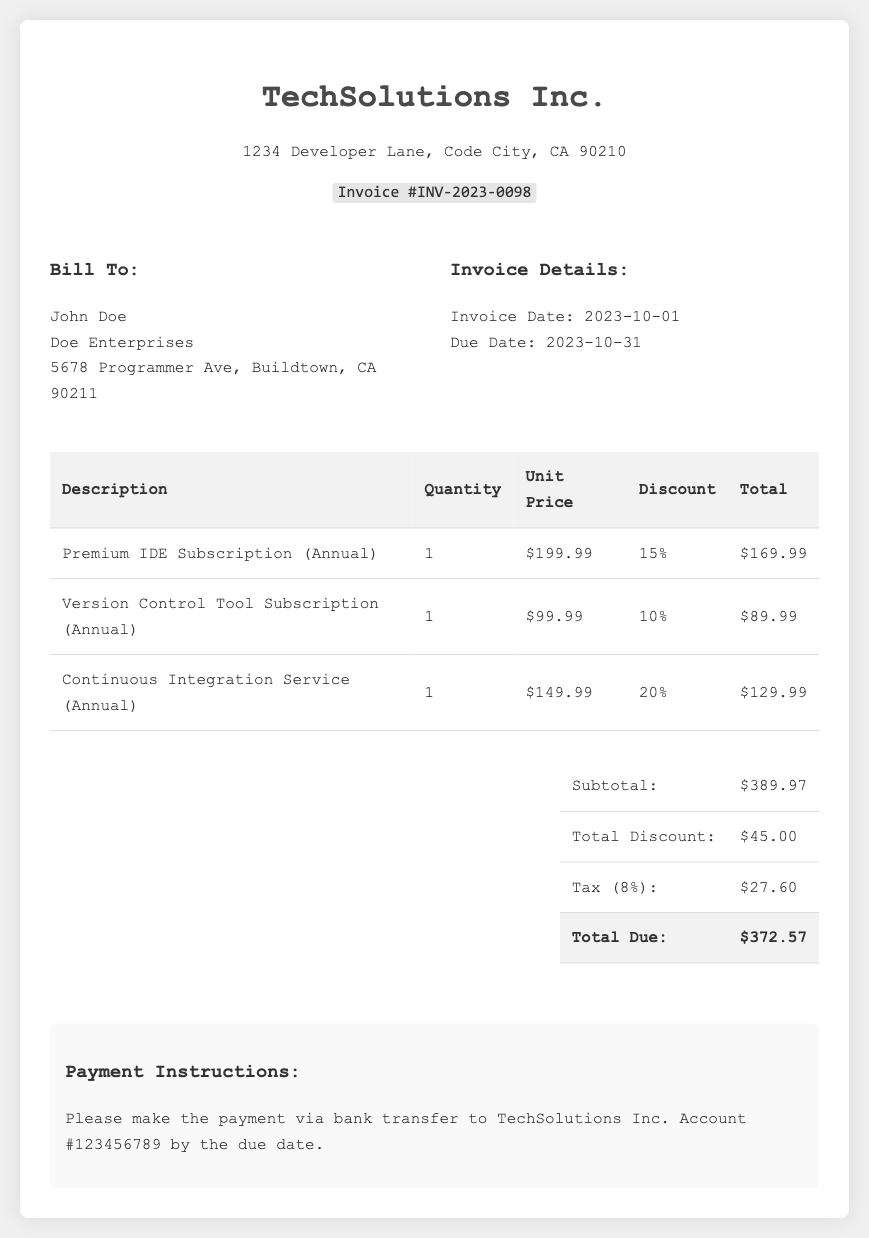What is the invoice number? The invoice number is listed prominently in the header of the document.
Answer: INV-2023-0098 What is the due date for the payment? The due date is specified under the invoice details section.
Answer: 2023-10-31 What is the subtotal before discounts? The subtotal is the total of all item prices before any deductions.
Answer: $389.97 What is the total discount applied to the invoice? The total discount is calculated and displayed in the total section of the invoice.
Answer: $45.00 What tax percentage is applied to the invoice total? The tax percentage is noted next to the tax amount in the total section.
Answer: 8% What is the total due amount? The total due is the final amount payable after discounts and tax are applied.
Answer: $372.57 How many different software subscriptions are listed? The number of unique software subscriptions can be counted from the itemized list provided in the table.
Answer: 3 Who is the invoice addressed to? The recipient's name is indicated in the "Bill To" section of the document.
Answer: John Doe What payment method is suggested in the invoice? The invoice includes a section with instructions suggesting a payment method.
Answer: bank transfer 